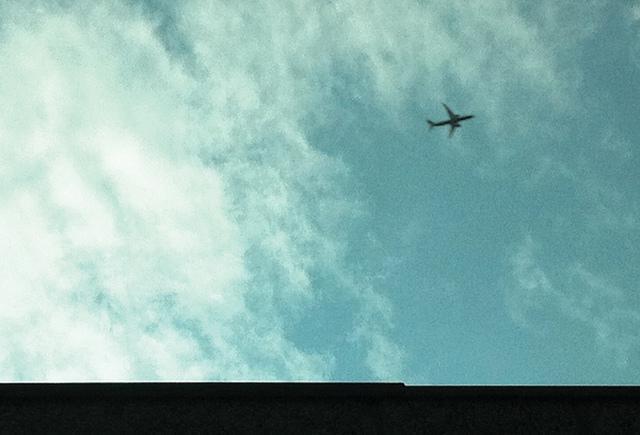How many birds are flying?
Give a very brief answer. 0. How many people have a blue umbrella?
Give a very brief answer. 0. 